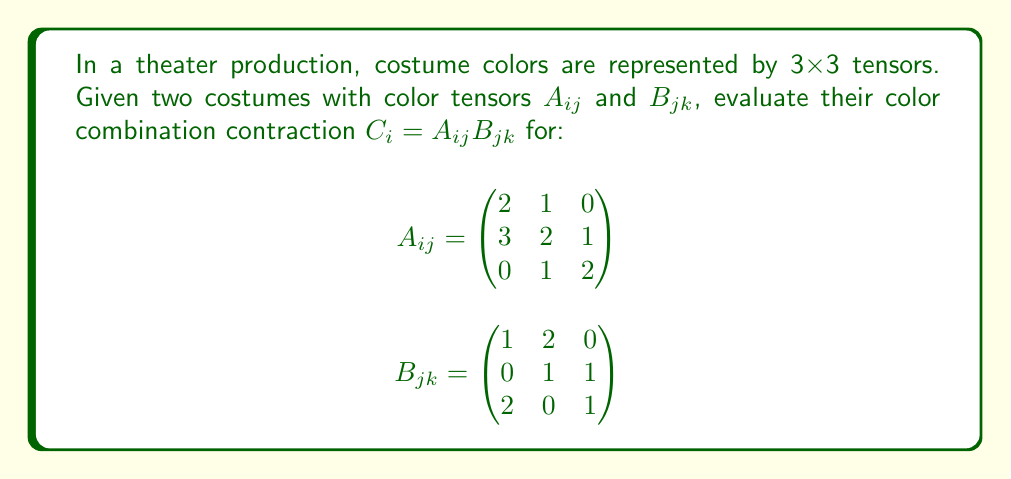Can you answer this question? To evaluate the contraction $C_i = A_{ij}B_{jk}$, we need to perform matrix multiplication between $A_{ij}$ and $B_{jk}$. This process can be broken down into steps:

1) The resulting tensor $C_i$ will be a 3x1 vector (or a 3x3 matrix with only one column filled).

2) We calculate each element of $C_i$ by multiplying the corresponding row of $A_{ij}$ with the first column of $B_{jk}$:

   $C_1 = (2)(1) + (1)(0) + (0)(2) = 2$
   
   $C_2 = (3)(1) + (2)(0) + (1)(2) = 5$
   
   $C_3 = (0)(1) + (1)(0) + (2)(2) = 4$

3) Therefore, the contraction results in:

   $$C_i = \begin{pmatrix}
   2 \\
   5 \\
   4
   \end{pmatrix}$$

This vector represents the combined color effect of the two costumes in the theater production.
Answer: $$C_i = \begin{pmatrix}
2 \\
5 \\
4
\end{pmatrix}$$ 